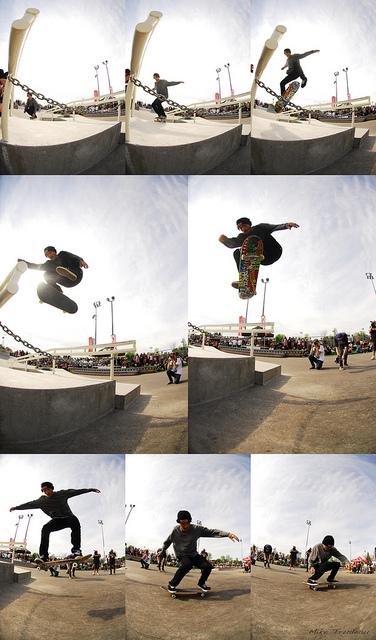Is someone doing skateboard tricks?
Be succinct. Yes. How many shots do you see in the college?
Answer briefly. 8. What is the person doing?
Short answer required. Skateboarding. 